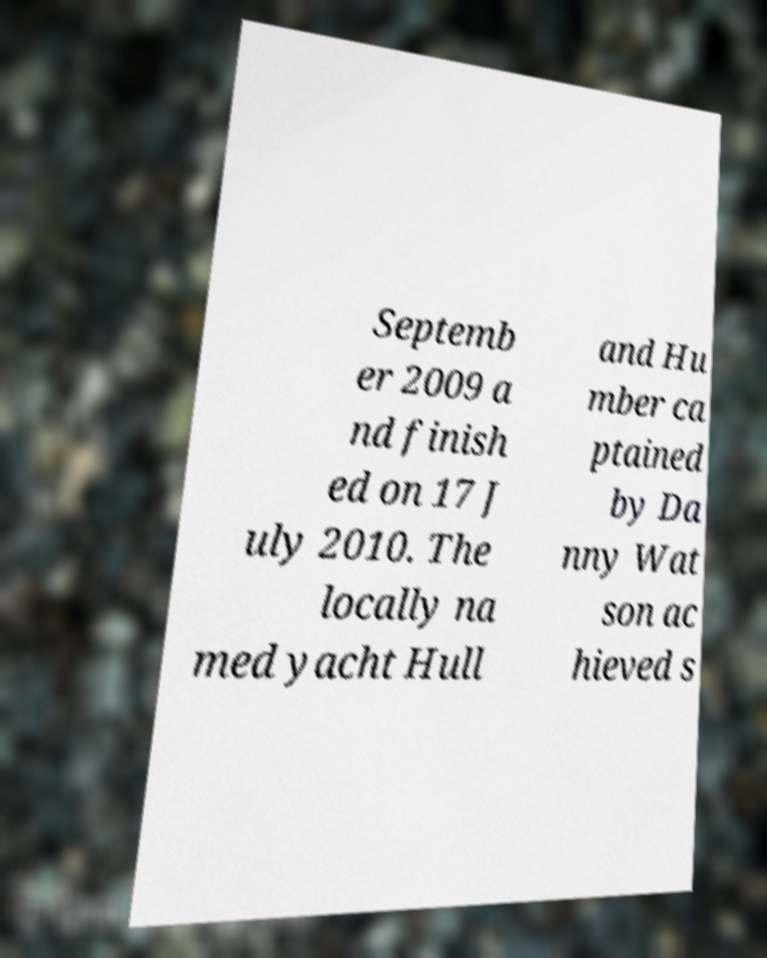I need the written content from this picture converted into text. Can you do that? Septemb er 2009 a nd finish ed on 17 J uly 2010. The locally na med yacht Hull and Hu mber ca ptained by Da nny Wat son ac hieved s 